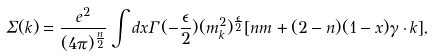Convert formula to latex. <formula><loc_0><loc_0><loc_500><loc_500>\Sigma ( k ) = { \frac { e ^ { 2 } } { ( 4 \pi ) ^ { \frac { n } { 2 } } } } \int d x \Gamma ( - { \frac { \epsilon } { 2 } } ) ( m _ { k } ^ { 2 } ) ^ { \frac { \epsilon } { 2 } } [ n m + ( 2 - n ) ( 1 - x ) \gamma \cdot k ] ,</formula> 